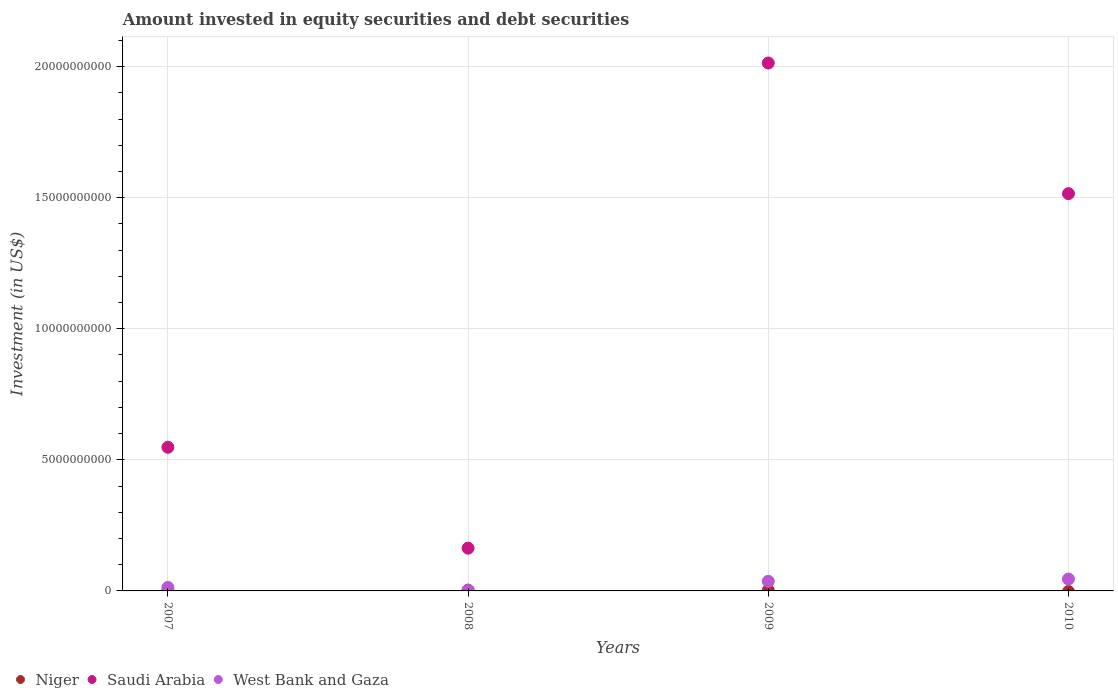How many different coloured dotlines are there?
Provide a succinct answer. 3. What is the amount invested in equity securities and debt securities in Niger in 2010?
Your answer should be very brief. 0. Across all years, what is the maximum amount invested in equity securities and debt securities in Niger?
Your answer should be compact. 3.02e+07. In which year was the amount invested in equity securities and debt securities in Saudi Arabia maximum?
Make the answer very short. 2009. What is the total amount invested in equity securities and debt securities in Niger in the graph?
Ensure brevity in your answer.  5.78e+07. What is the difference between the amount invested in equity securities and debt securities in West Bank and Gaza in 2009 and that in 2010?
Provide a succinct answer. -8.66e+07. What is the difference between the amount invested in equity securities and debt securities in Niger in 2007 and the amount invested in equity securities and debt securities in Saudi Arabia in 2008?
Give a very brief answer. -1.62e+09. What is the average amount invested in equity securities and debt securities in West Bank and Gaza per year?
Your answer should be very brief. 2.44e+08. In the year 2008, what is the difference between the amount invested in equity securities and debt securities in Niger and amount invested in equity securities and debt securities in West Bank and Gaza?
Keep it short and to the point. 5.50e+06. What is the ratio of the amount invested in equity securities and debt securities in Niger in 2007 to that in 2008?
Make the answer very short. 0.27. What is the difference between the highest and the second highest amount invested in equity securities and debt securities in Saudi Arabia?
Make the answer very short. 4.98e+09. What is the difference between the highest and the lowest amount invested in equity securities and debt securities in West Bank and Gaza?
Provide a succinct answer. 4.29e+08. How many dotlines are there?
Offer a terse response. 3. What is the difference between two consecutive major ticks on the Y-axis?
Keep it short and to the point. 5.00e+09. Does the graph contain grids?
Keep it short and to the point. Yes. Where does the legend appear in the graph?
Keep it short and to the point. Bottom left. What is the title of the graph?
Make the answer very short. Amount invested in equity securities and debt securities. What is the label or title of the Y-axis?
Your answer should be very brief. Investment (in US$). What is the Investment (in US$) of Niger in 2007?
Keep it short and to the point. 8.14e+06. What is the Investment (in US$) of Saudi Arabia in 2007?
Keep it short and to the point. 5.48e+09. What is the Investment (in US$) in West Bank and Gaza in 2007?
Keep it short and to the point. 1.31e+08. What is the Investment (in US$) of Niger in 2008?
Make the answer very short. 3.02e+07. What is the Investment (in US$) in Saudi Arabia in 2008?
Your answer should be compact. 1.63e+09. What is the Investment (in US$) in West Bank and Gaza in 2008?
Make the answer very short. 2.47e+07. What is the Investment (in US$) of Niger in 2009?
Your response must be concise. 1.95e+07. What is the Investment (in US$) of Saudi Arabia in 2009?
Offer a terse response. 2.01e+1. What is the Investment (in US$) in West Bank and Gaza in 2009?
Make the answer very short. 3.67e+08. What is the Investment (in US$) of Saudi Arabia in 2010?
Offer a terse response. 1.52e+1. What is the Investment (in US$) of West Bank and Gaza in 2010?
Your response must be concise. 4.53e+08. Across all years, what is the maximum Investment (in US$) of Niger?
Provide a short and direct response. 3.02e+07. Across all years, what is the maximum Investment (in US$) of Saudi Arabia?
Your answer should be compact. 2.01e+1. Across all years, what is the maximum Investment (in US$) in West Bank and Gaza?
Ensure brevity in your answer.  4.53e+08. Across all years, what is the minimum Investment (in US$) in Saudi Arabia?
Give a very brief answer. 1.63e+09. Across all years, what is the minimum Investment (in US$) in West Bank and Gaza?
Offer a terse response. 2.47e+07. What is the total Investment (in US$) of Niger in the graph?
Your answer should be very brief. 5.78e+07. What is the total Investment (in US$) in Saudi Arabia in the graph?
Your answer should be compact. 4.24e+1. What is the total Investment (in US$) in West Bank and Gaza in the graph?
Provide a succinct answer. 9.76e+08. What is the difference between the Investment (in US$) in Niger in 2007 and that in 2008?
Offer a terse response. -2.20e+07. What is the difference between the Investment (in US$) in Saudi Arabia in 2007 and that in 2008?
Give a very brief answer. 3.85e+09. What is the difference between the Investment (in US$) of West Bank and Gaza in 2007 and that in 2008?
Make the answer very short. 1.06e+08. What is the difference between the Investment (in US$) of Niger in 2007 and that in 2009?
Your answer should be compact. -1.13e+07. What is the difference between the Investment (in US$) of Saudi Arabia in 2007 and that in 2009?
Give a very brief answer. -1.47e+1. What is the difference between the Investment (in US$) of West Bank and Gaza in 2007 and that in 2009?
Your response must be concise. -2.36e+08. What is the difference between the Investment (in US$) of Saudi Arabia in 2007 and that in 2010?
Provide a succinct answer. -9.67e+09. What is the difference between the Investment (in US$) in West Bank and Gaza in 2007 and that in 2010?
Keep it short and to the point. -3.23e+08. What is the difference between the Investment (in US$) in Niger in 2008 and that in 2009?
Keep it short and to the point. 1.07e+07. What is the difference between the Investment (in US$) of Saudi Arabia in 2008 and that in 2009?
Offer a terse response. -1.85e+1. What is the difference between the Investment (in US$) in West Bank and Gaza in 2008 and that in 2009?
Provide a succinct answer. -3.42e+08. What is the difference between the Investment (in US$) in Saudi Arabia in 2008 and that in 2010?
Provide a short and direct response. -1.35e+1. What is the difference between the Investment (in US$) in West Bank and Gaza in 2008 and that in 2010?
Provide a short and direct response. -4.29e+08. What is the difference between the Investment (in US$) in Saudi Arabia in 2009 and that in 2010?
Your answer should be very brief. 4.98e+09. What is the difference between the Investment (in US$) of West Bank and Gaza in 2009 and that in 2010?
Keep it short and to the point. -8.66e+07. What is the difference between the Investment (in US$) of Niger in 2007 and the Investment (in US$) of Saudi Arabia in 2008?
Provide a short and direct response. -1.62e+09. What is the difference between the Investment (in US$) in Niger in 2007 and the Investment (in US$) in West Bank and Gaza in 2008?
Your response must be concise. -1.65e+07. What is the difference between the Investment (in US$) of Saudi Arabia in 2007 and the Investment (in US$) of West Bank and Gaza in 2008?
Offer a terse response. 5.45e+09. What is the difference between the Investment (in US$) of Niger in 2007 and the Investment (in US$) of Saudi Arabia in 2009?
Keep it short and to the point. -2.01e+1. What is the difference between the Investment (in US$) in Niger in 2007 and the Investment (in US$) in West Bank and Gaza in 2009?
Make the answer very short. -3.59e+08. What is the difference between the Investment (in US$) of Saudi Arabia in 2007 and the Investment (in US$) of West Bank and Gaza in 2009?
Your answer should be very brief. 5.11e+09. What is the difference between the Investment (in US$) of Niger in 2007 and the Investment (in US$) of Saudi Arabia in 2010?
Provide a short and direct response. -1.51e+1. What is the difference between the Investment (in US$) of Niger in 2007 and the Investment (in US$) of West Bank and Gaza in 2010?
Keep it short and to the point. -4.45e+08. What is the difference between the Investment (in US$) in Saudi Arabia in 2007 and the Investment (in US$) in West Bank and Gaza in 2010?
Your response must be concise. 5.03e+09. What is the difference between the Investment (in US$) in Niger in 2008 and the Investment (in US$) in Saudi Arabia in 2009?
Keep it short and to the point. -2.01e+1. What is the difference between the Investment (in US$) of Niger in 2008 and the Investment (in US$) of West Bank and Gaza in 2009?
Keep it short and to the point. -3.37e+08. What is the difference between the Investment (in US$) in Saudi Arabia in 2008 and the Investment (in US$) in West Bank and Gaza in 2009?
Provide a short and direct response. 1.26e+09. What is the difference between the Investment (in US$) of Niger in 2008 and the Investment (in US$) of Saudi Arabia in 2010?
Ensure brevity in your answer.  -1.51e+1. What is the difference between the Investment (in US$) in Niger in 2008 and the Investment (in US$) in West Bank and Gaza in 2010?
Keep it short and to the point. -4.23e+08. What is the difference between the Investment (in US$) of Saudi Arabia in 2008 and the Investment (in US$) of West Bank and Gaza in 2010?
Give a very brief answer. 1.18e+09. What is the difference between the Investment (in US$) in Niger in 2009 and the Investment (in US$) in Saudi Arabia in 2010?
Provide a short and direct response. -1.51e+1. What is the difference between the Investment (in US$) of Niger in 2009 and the Investment (in US$) of West Bank and Gaza in 2010?
Your answer should be very brief. -4.34e+08. What is the difference between the Investment (in US$) of Saudi Arabia in 2009 and the Investment (in US$) of West Bank and Gaza in 2010?
Provide a succinct answer. 1.97e+1. What is the average Investment (in US$) in Niger per year?
Your response must be concise. 1.44e+07. What is the average Investment (in US$) in Saudi Arabia per year?
Ensure brevity in your answer.  1.06e+1. What is the average Investment (in US$) in West Bank and Gaza per year?
Provide a short and direct response. 2.44e+08. In the year 2007, what is the difference between the Investment (in US$) of Niger and Investment (in US$) of Saudi Arabia?
Provide a short and direct response. -5.47e+09. In the year 2007, what is the difference between the Investment (in US$) of Niger and Investment (in US$) of West Bank and Gaza?
Your answer should be compact. -1.23e+08. In the year 2007, what is the difference between the Investment (in US$) of Saudi Arabia and Investment (in US$) of West Bank and Gaza?
Offer a terse response. 5.35e+09. In the year 2008, what is the difference between the Investment (in US$) of Niger and Investment (in US$) of Saudi Arabia?
Your answer should be very brief. -1.60e+09. In the year 2008, what is the difference between the Investment (in US$) in Niger and Investment (in US$) in West Bank and Gaza?
Your response must be concise. 5.50e+06. In the year 2008, what is the difference between the Investment (in US$) in Saudi Arabia and Investment (in US$) in West Bank and Gaza?
Provide a short and direct response. 1.61e+09. In the year 2009, what is the difference between the Investment (in US$) in Niger and Investment (in US$) in Saudi Arabia?
Provide a short and direct response. -2.01e+1. In the year 2009, what is the difference between the Investment (in US$) of Niger and Investment (in US$) of West Bank and Gaza?
Offer a terse response. -3.47e+08. In the year 2009, what is the difference between the Investment (in US$) in Saudi Arabia and Investment (in US$) in West Bank and Gaza?
Provide a short and direct response. 1.98e+1. In the year 2010, what is the difference between the Investment (in US$) of Saudi Arabia and Investment (in US$) of West Bank and Gaza?
Provide a short and direct response. 1.47e+1. What is the ratio of the Investment (in US$) of Niger in 2007 to that in 2008?
Offer a very short reply. 0.27. What is the ratio of the Investment (in US$) of Saudi Arabia in 2007 to that in 2008?
Offer a terse response. 3.36. What is the ratio of the Investment (in US$) of West Bank and Gaza in 2007 to that in 2008?
Your answer should be very brief. 5.3. What is the ratio of the Investment (in US$) in Niger in 2007 to that in 2009?
Provide a short and direct response. 0.42. What is the ratio of the Investment (in US$) of Saudi Arabia in 2007 to that in 2009?
Offer a terse response. 0.27. What is the ratio of the Investment (in US$) of West Bank and Gaza in 2007 to that in 2009?
Offer a very short reply. 0.36. What is the ratio of the Investment (in US$) of Saudi Arabia in 2007 to that in 2010?
Your answer should be compact. 0.36. What is the ratio of the Investment (in US$) in West Bank and Gaza in 2007 to that in 2010?
Keep it short and to the point. 0.29. What is the ratio of the Investment (in US$) in Niger in 2008 to that in 2009?
Your response must be concise. 1.55. What is the ratio of the Investment (in US$) of Saudi Arabia in 2008 to that in 2009?
Offer a very short reply. 0.08. What is the ratio of the Investment (in US$) in West Bank and Gaza in 2008 to that in 2009?
Your answer should be compact. 0.07. What is the ratio of the Investment (in US$) in Saudi Arabia in 2008 to that in 2010?
Give a very brief answer. 0.11. What is the ratio of the Investment (in US$) in West Bank and Gaza in 2008 to that in 2010?
Provide a succinct answer. 0.05. What is the ratio of the Investment (in US$) of Saudi Arabia in 2009 to that in 2010?
Your answer should be very brief. 1.33. What is the ratio of the Investment (in US$) of West Bank and Gaza in 2009 to that in 2010?
Offer a very short reply. 0.81. What is the difference between the highest and the second highest Investment (in US$) of Niger?
Ensure brevity in your answer.  1.07e+07. What is the difference between the highest and the second highest Investment (in US$) in Saudi Arabia?
Give a very brief answer. 4.98e+09. What is the difference between the highest and the second highest Investment (in US$) of West Bank and Gaza?
Your response must be concise. 8.66e+07. What is the difference between the highest and the lowest Investment (in US$) of Niger?
Offer a very short reply. 3.02e+07. What is the difference between the highest and the lowest Investment (in US$) of Saudi Arabia?
Provide a succinct answer. 1.85e+1. What is the difference between the highest and the lowest Investment (in US$) of West Bank and Gaza?
Your response must be concise. 4.29e+08. 